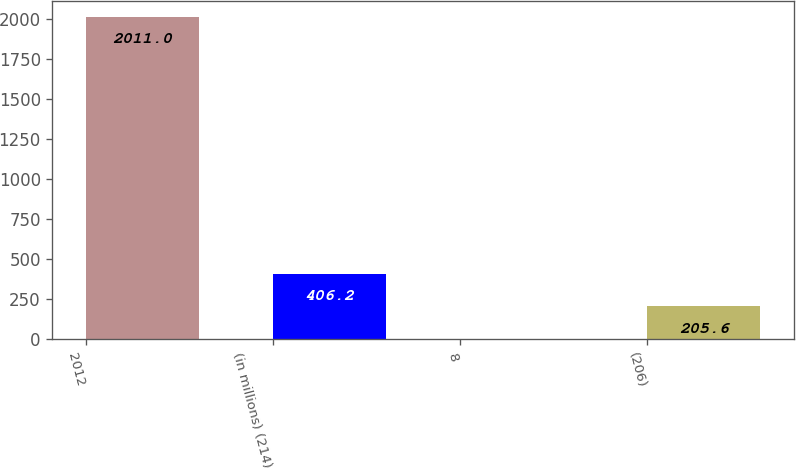<chart> <loc_0><loc_0><loc_500><loc_500><bar_chart><fcel>2012<fcel>(in millions) (214)<fcel>8<fcel>(206)<nl><fcel>2011<fcel>406.2<fcel>5<fcel>205.6<nl></chart> 